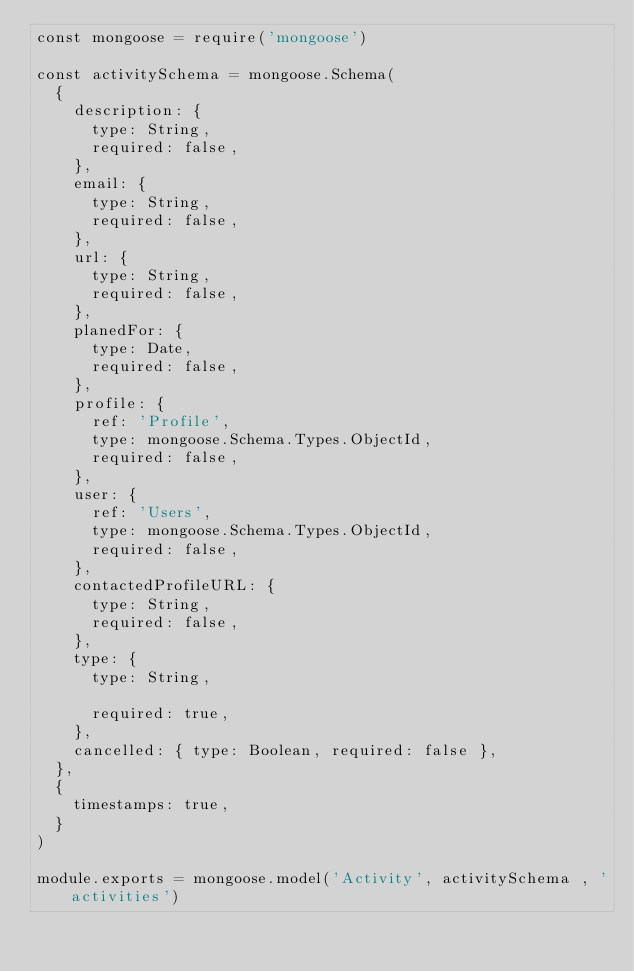<code> <loc_0><loc_0><loc_500><loc_500><_JavaScript_>const mongoose = require('mongoose')

const activitySchema = mongoose.Schema(
  {
    description: {
      type: String,
      required: false,
    },
    email: {
      type: String,
      required: false,
    },
    url: {
      type: String,
      required: false,
    },
    planedFor: {
      type: Date,
      required: false,
    },
    profile: {
      ref: 'Profile',
      type: mongoose.Schema.Types.ObjectId,
      required: false,
    },
    user: {
      ref: 'Users',
      type: mongoose.Schema.Types.ObjectId,
      required: false,
    },
    contactedProfileURL: {
      type: String,
      required: false,
    },
    type: {
      type: String,

      required: true,
    },
    cancelled: { type: Boolean, required: false },
  },
  {
    timestamps: true,
  }
)

module.exports = mongoose.model('Activity', activitySchema , 'activities')
</code> 